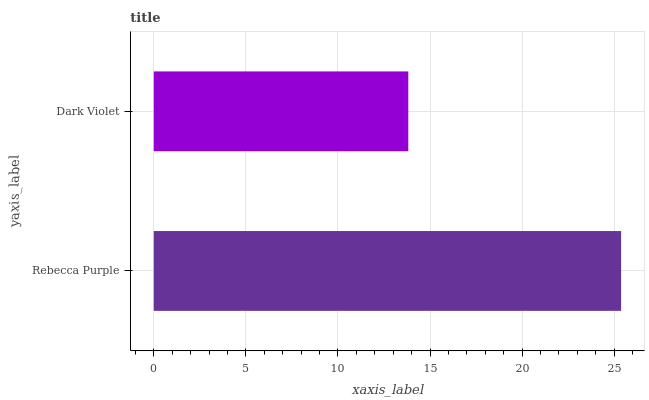Is Dark Violet the minimum?
Answer yes or no. Yes. Is Rebecca Purple the maximum?
Answer yes or no. Yes. Is Dark Violet the maximum?
Answer yes or no. No. Is Rebecca Purple greater than Dark Violet?
Answer yes or no. Yes. Is Dark Violet less than Rebecca Purple?
Answer yes or no. Yes. Is Dark Violet greater than Rebecca Purple?
Answer yes or no. No. Is Rebecca Purple less than Dark Violet?
Answer yes or no. No. Is Rebecca Purple the high median?
Answer yes or no. Yes. Is Dark Violet the low median?
Answer yes or no. Yes. Is Dark Violet the high median?
Answer yes or no. No. Is Rebecca Purple the low median?
Answer yes or no. No. 